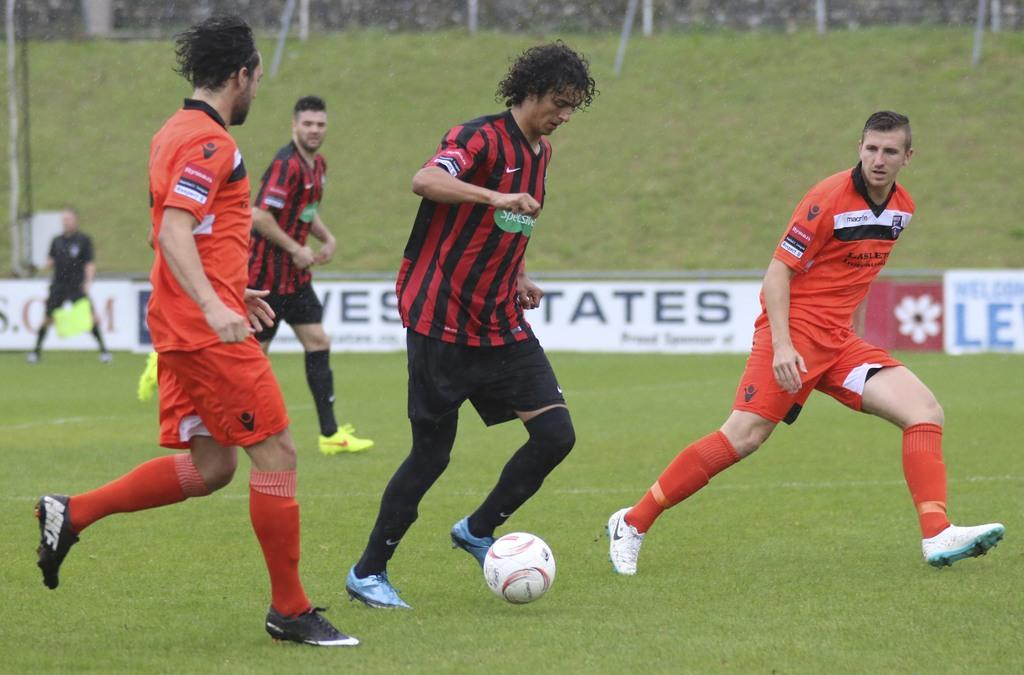Who or what can be seen in the image? There are people in the image. What object is present in the image? There is a ball in the image. What can be seen behind the people and the ball? There is a background in the image, which includes more people and a board. Is there a boat visible in the image? No, there is no boat present in the image. What season is it in the image? The provided facts do not mention the season, so it cannot be determined from the image. 